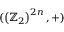<formula> <loc_0><loc_0><loc_500><loc_500>( \left ( \mathbb { Z } _ { 2 } \right ) ^ { 2 n } , + )</formula> 